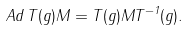Convert formula to latex. <formula><loc_0><loc_0><loc_500><loc_500>A d \, T ( g ) M = T ( g ) M T ^ { - 1 } ( g ) .</formula> 